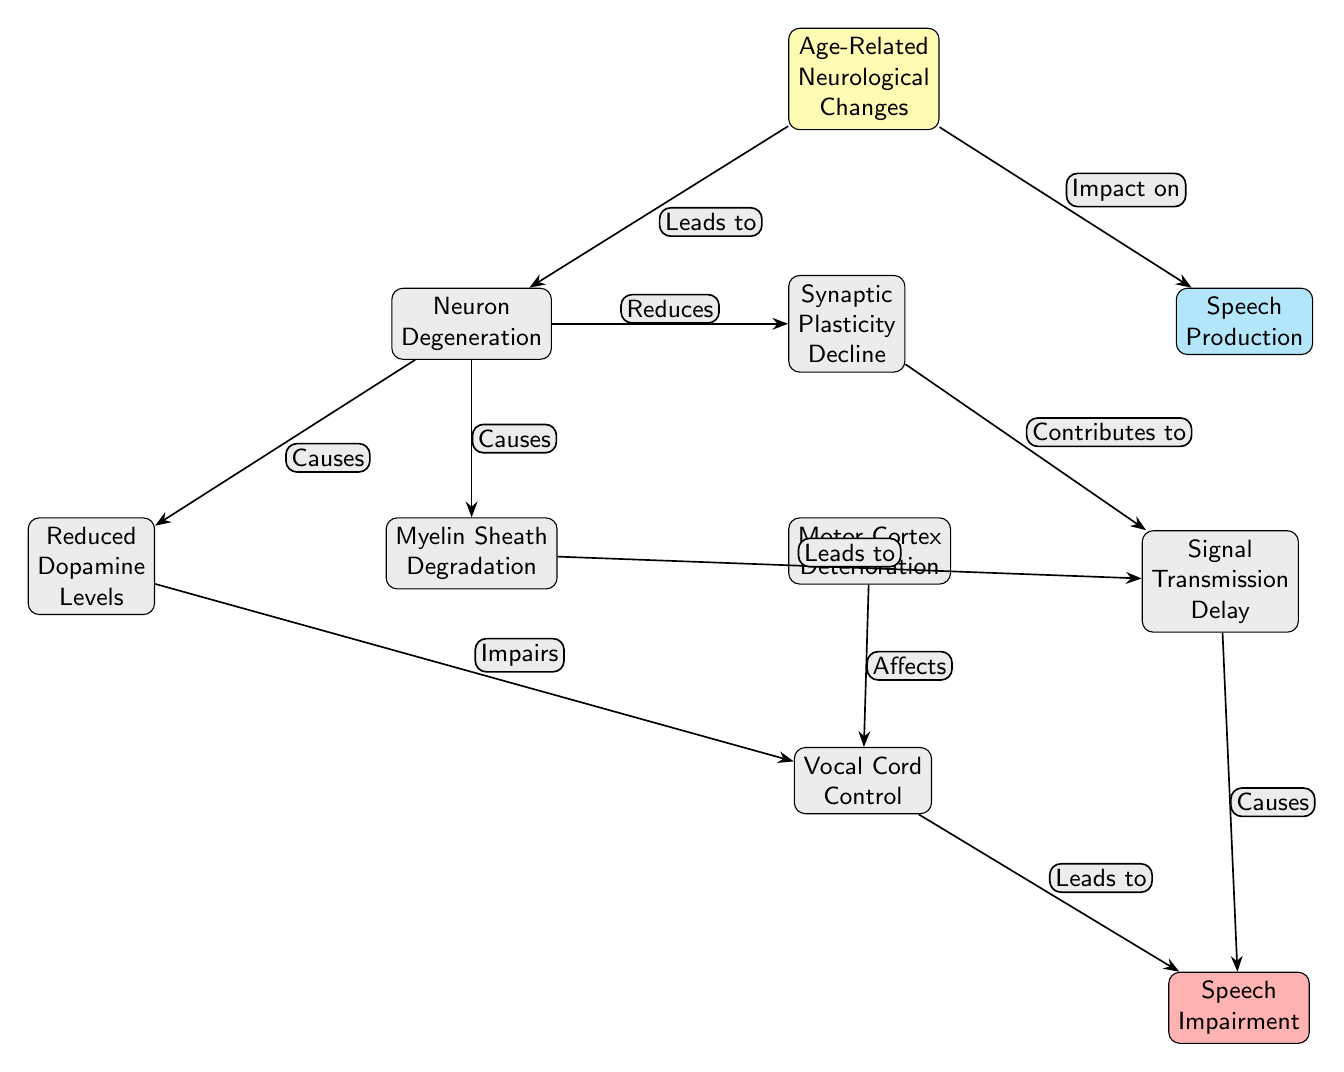What is the central theme of this diagram? The diagram revolves around "Age-Related Neurological Changes," displayed at the top as the central node, which connects to various effects on speech production.
Answer: Age-Related Neurological Changes How many primary nodes are there in the diagram? The diagram contains a total of 10 primary nodes, including the central theme and its effects and related factors.
Answer: 10 What is the relationship between "Neuron Degeneration" and "Reduced Dopamine Levels"? The diagram indicates that "Neuron Degeneration" leads to "Reduced Dopamine Levels," as shown by an arrow annotated with "Causes."
Answer: Causes Which node is directly affected by "Motor Cortex Deterioration"? The node "Vocal Cord Control" is directly affected by "Motor Cortex Deterioration," as indicated by the arrow labeled "Affects."
Answer: Vocal Cord Control What contributes to "Signal Transmission Delay"? "Synaptic Plasticity Decline" is labeled as contributing to "Signal Transmission Delay" in the diagram, as shown by the connecting arrow.
Answer: Synaptic Plasticity Decline Describe the flow from "Age-Related Neurological Changes" to "Speech Impairment." The flow starts at "Age-Related Neurological Changes," which leads to "Neuron Degeneration." This then causes "Reduced Dopamine Levels," "Myelin Sheath Degradation," and "Synaptic Plasticity Decline." Both "Vocal Cord Control" and "Signal Transmission Delay" emerge from these nodes, ultimately leading to "Speech Impairment."
Answer: Age-Related Neurological Changes → Neuron Degeneration → Reduced Dopamine Levels/Myelin Sheath Degradation/Synaptic Plasticity Decline → Vocal Cord Control/Signal Transmission Delay → Speech Impairment What are the two consequences of "Myelin Sheath Degradation"? The two consequences listed are "Vocal Cord Control" and "Signal Transmission Delay," as indicated by arrows leading from "Myelin Sheath Degradation."
Answer: Vocal Cord Control, Signal Transmission Delay Is there a direct effect from "Reduced Dopamine Levels" to "Speech Impairment"? There is no direct connection from "Reduced Dopamine Levels" to "Speech Impairment," as the relationship flows through "Vocal Cord Control." The diagram does not show a direct arrow.
Answer: No What other node besides "Neuron Degeneration" does "Age-Related Neurological Changes" directly lead to? "Speech Production" is the other node that "Age-Related Neurological Changes" directly leads to, as shown by the arrow labeled "Impact on."
Answer: Speech Production 